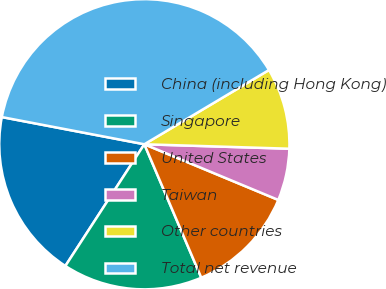<chart> <loc_0><loc_0><loc_500><loc_500><pie_chart><fcel>China (including Hong Kong)<fcel>Singapore<fcel>United States<fcel>Taiwan<fcel>Other countries<fcel>Total net revenue<nl><fcel>18.84%<fcel>15.58%<fcel>12.31%<fcel>5.78%<fcel>9.04%<fcel>38.45%<nl></chart> 